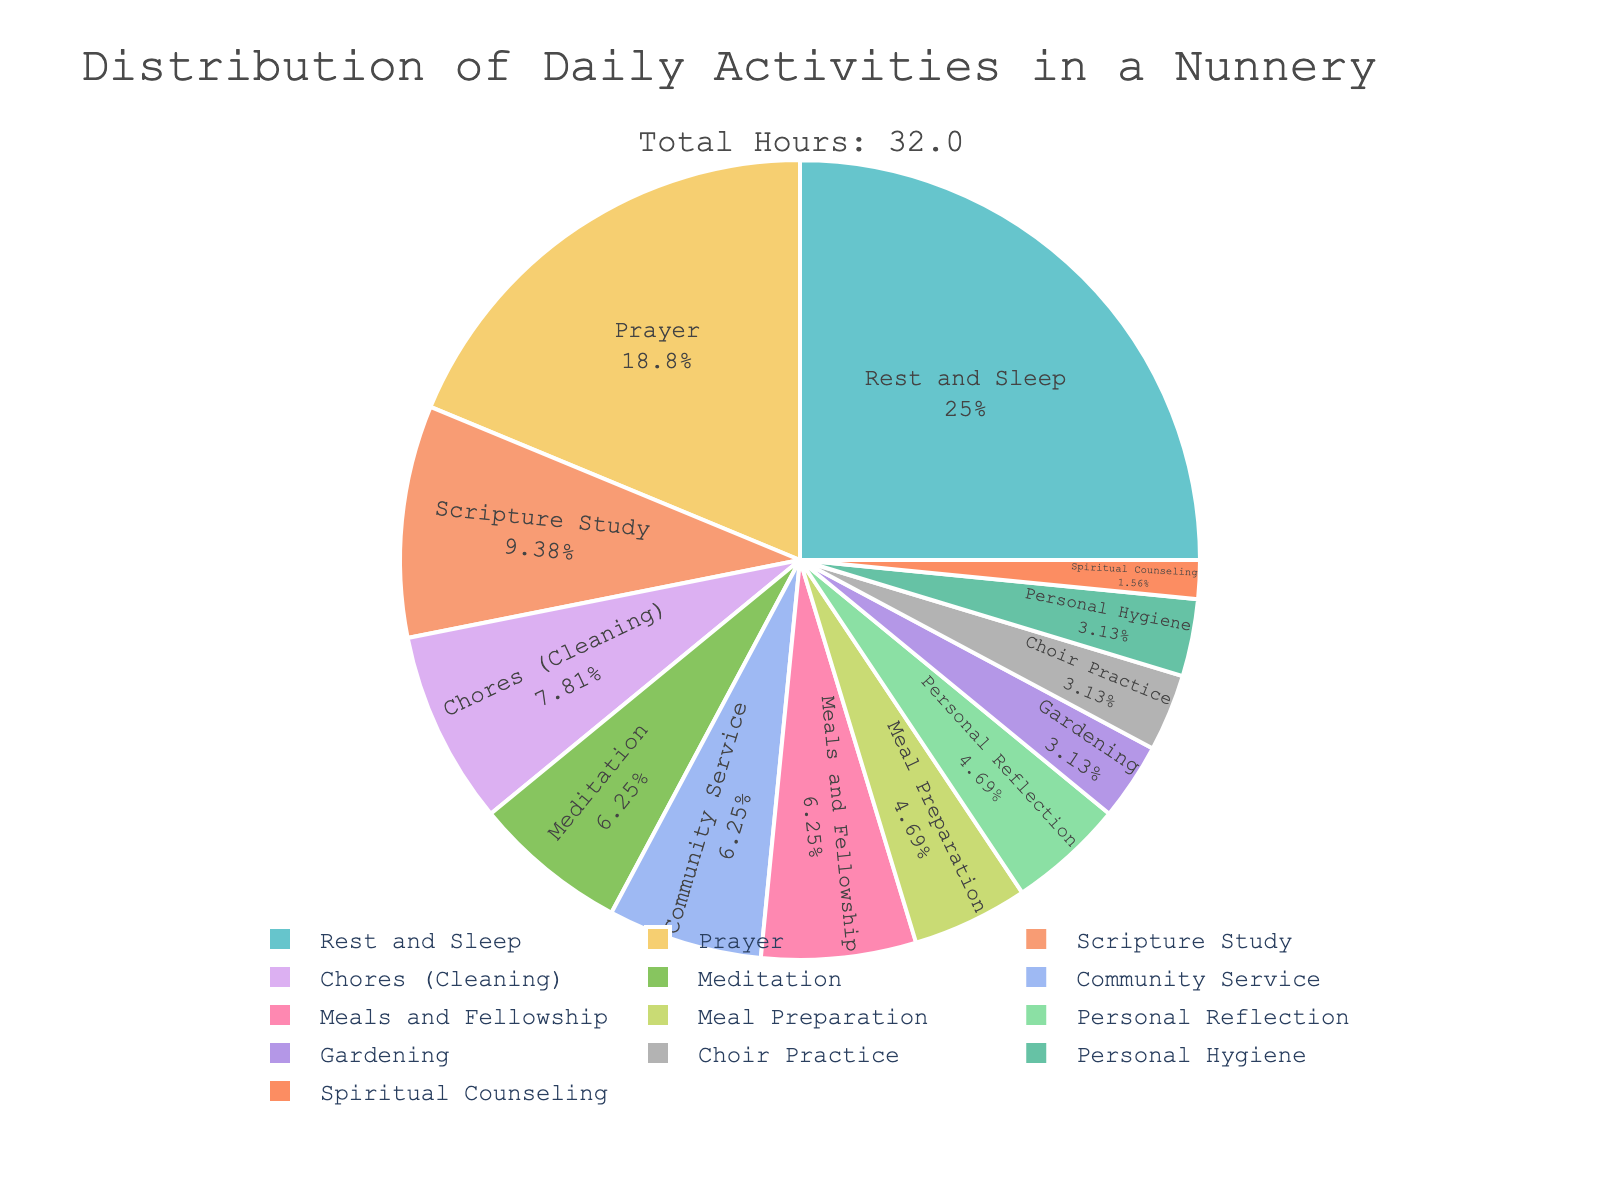What activity takes the most hours per day? The pie chart shows the activity distribution, and the largest segment represents the activity with the most hours. In this case, the biggest segment indicates Rest and Sleep, with 8 hours.
Answer: Rest and Sleep How much time is spent on prayer daily? By looking at the labeled segments in the pie chart, we can see that 'Prayer' has an allocated time of 6 hours per day.
Answer: 6 hours Which takes up more time, Chores (Cleaning) or Meal Preparation? The pie chart shows that Chores (Cleaning) are allotted 2.5 hours, while Meal Preparation is given 1.5 hours. Therefore, Chores (Cleaning) takes more time.
Answer: Chores (Cleaning) What is the combined total of hours spent on meal-related activities (Meal Preparation, Meals and Fellowship)? First, identify the hours for each activity: Meal Preparation is 1.5 hours, and Meals and Fellowship is 2 hours. Adding those gives 1.5 + 2 = 3.5 hours.
Answer: 3.5 hours What percentage of the day is spent on Scripture Study? The pie chart indicates that 3 hours are spent on Scripture Study. Given a 24-hour day, the percentage is calculated as (3/24) * 100% = 12.5%.
Answer: 12.5% How does the time allocated for Personal Reflection compare to Personal Hygiene? The pie chart shows that Personal Reflection is allocated 1.5 hours, while Personal Hygiene is 1 hour. Therefore, more time is spent on Personal Reflection.
Answer: Personal Reflection What is the least time-consuming activity? The smallest segment of the pie chart represents the least time-consuming activity, which is Spiritual Counseling at 0.5 hours.
Answer: Spiritual Counseling Compare the total hours spent on Rest and Sleep with Prayer and Scripture Study combined. Rest and Sleep are allocated 8 hours. Prayer and Scripture Study combined are 6 + 3 = 9 hours. So, more time is spent on Prayer and Scripture Study combined.
Answer: Prayer and Scripture Study How much less is the time dedicated to Gardening compared to Chores (Cleaning)? Gardening is given 1 hour, and Chores (Cleaning) 2.5 hours. The difference is 2.5 - 1 = 1.5 hours.
Answer: 1.5 hours Is the time spent on Meals and Fellowship more, less, or equal to Community Service? The pie chart shows that both Meals and Fellowship and Community Service are each allocated 2 hours. Therefore, the time spent on both activities is equal.
Answer: Equal 